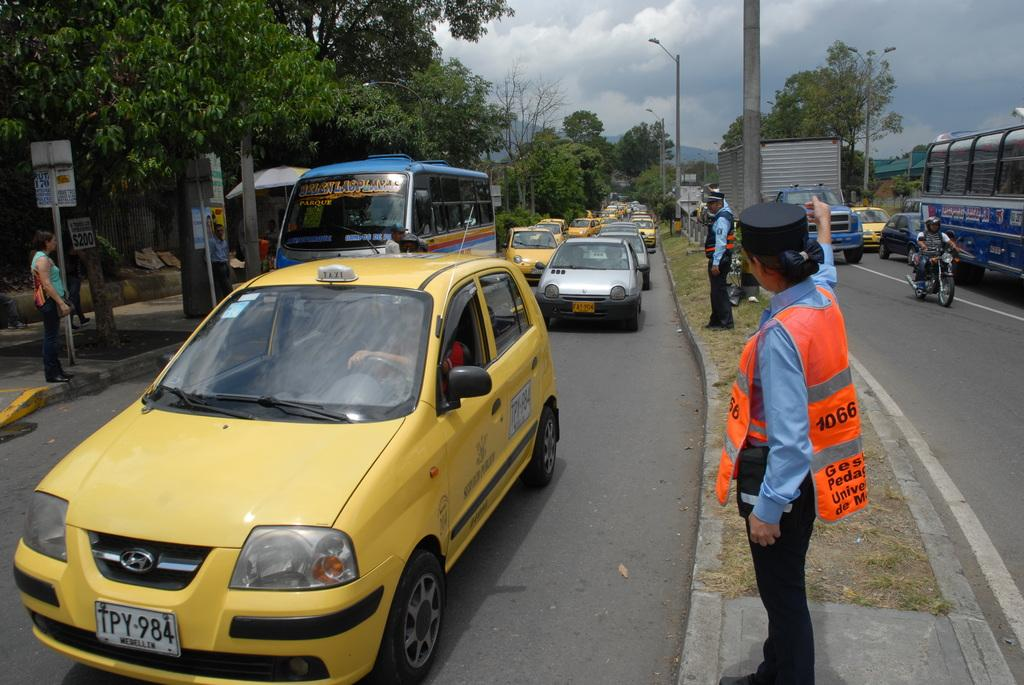<image>
Render a clear and concise summary of the photo. a license plat with TPY on the front 